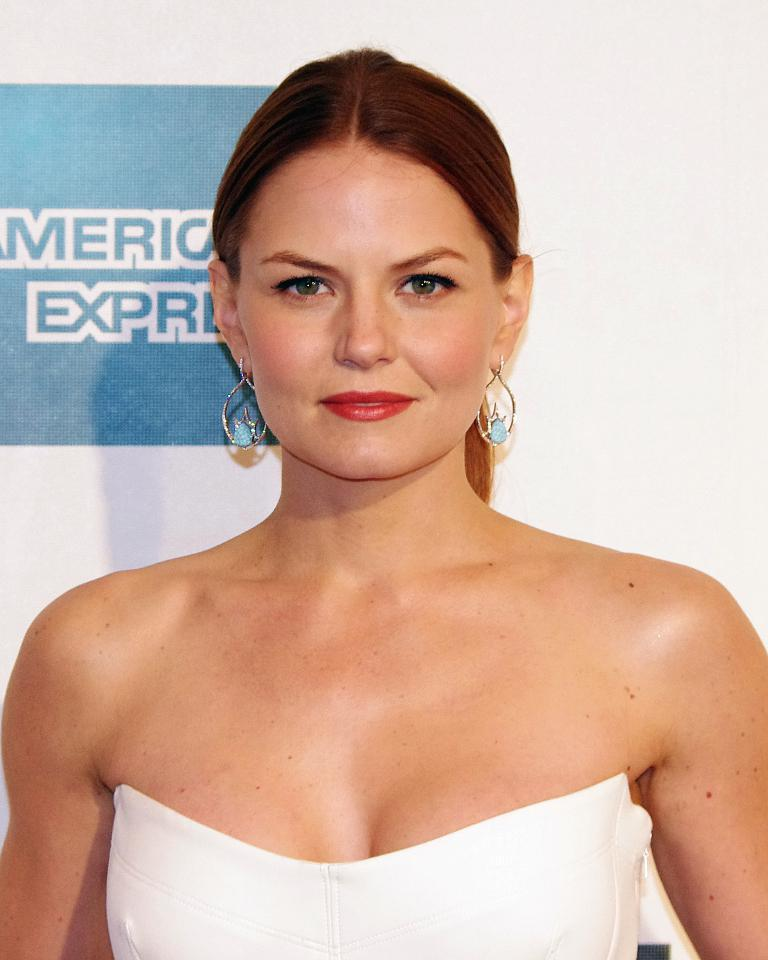Who is the main subject in the image? There is a woman in the image. What is the woman wearing? The woman is wearing a white dress. What is the background of the image? The woman is standing in front of a white wall. Is there any text or symbol present in the image? Yes, there is a logo on the left side of the image. What type of fruit is being held by the lizards in the image? There are no lizards or fruit present in the image; it features a woman standing in front of a white wall with a logo on the left side. 